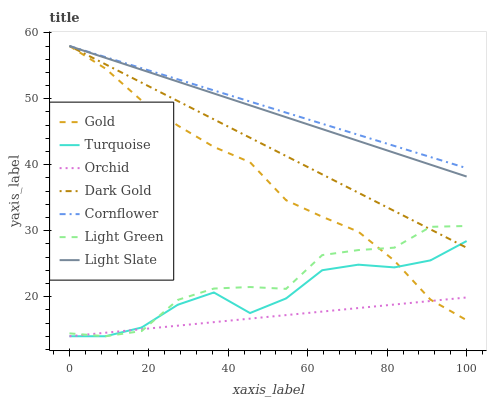Does Turquoise have the minimum area under the curve?
Answer yes or no. No. Does Turquoise have the maximum area under the curve?
Answer yes or no. No. Is Turquoise the smoothest?
Answer yes or no. No. Is Turquoise the roughest?
Answer yes or no. No. Does Gold have the lowest value?
Answer yes or no. No. Does Turquoise have the highest value?
Answer yes or no. No. Is Light Green less than Light Slate?
Answer yes or no. Yes. Is Light Slate greater than Light Green?
Answer yes or no. Yes. Does Light Green intersect Light Slate?
Answer yes or no. No. 